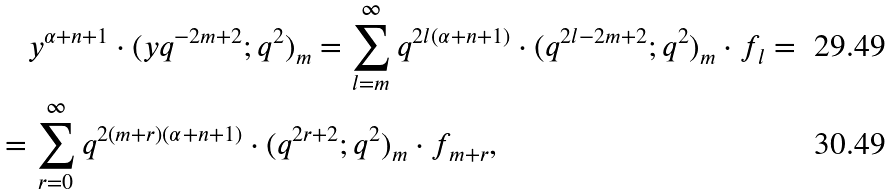<formula> <loc_0><loc_0><loc_500><loc_500>& \quad y ^ { \alpha + n + 1 } \cdot ( y q ^ { - 2 m + 2 } ; q ^ { 2 } ) _ { m } = \sum _ { l = m } ^ { \infty } q ^ { 2 l ( \alpha + n + 1 ) } \cdot ( q ^ { 2 l - 2 m + 2 } ; q ^ { 2 } ) _ { m } \cdot f _ { l } = \\ & = \sum _ { r = 0 } ^ { \infty } q ^ { 2 ( m + r ) ( \alpha + n + 1 ) } \cdot ( q ^ { 2 r + 2 } ; q ^ { 2 } ) _ { m } \cdot f _ { m + r } ,</formula> 